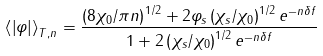<formula> <loc_0><loc_0><loc_500><loc_500>\left \langle { \left | \varphi \right | } \right \rangle _ { T , n } = \frac { { \left ( { 8 \chi _ { 0 } / \pi n } \right ) ^ { 1 / 2 } + 2 \varphi _ { s } \left ( { \chi _ { s } / \chi _ { 0 } } \right ) ^ { 1 / 2 } e ^ { - n \delta f } } } { { 1 + 2 \left ( { \chi _ { s } / \chi _ { 0 } } \right ) ^ { 1 / 2 } e ^ { - n \delta f } } }</formula> 